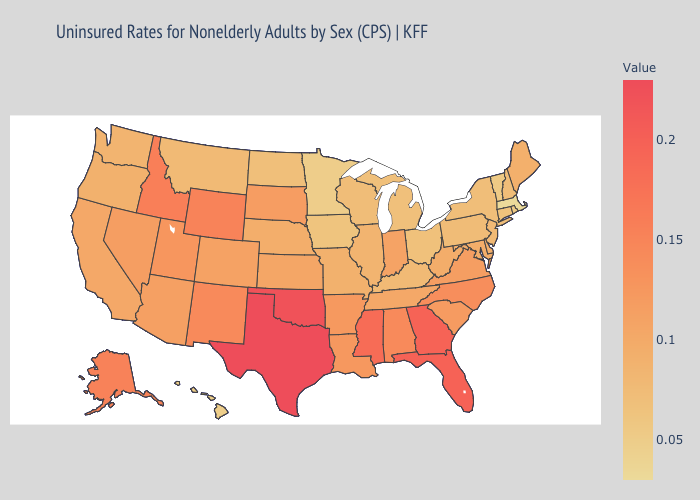Does Massachusetts have the lowest value in the Northeast?
Concise answer only. Yes. Among the states that border New Hampshire , does Vermont have the lowest value?
Short answer required. No. Among the states that border Ohio , does Indiana have the highest value?
Short answer required. Yes. Among the states that border West Virginia , does Maryland have the highest value?
Short answer required. No. 